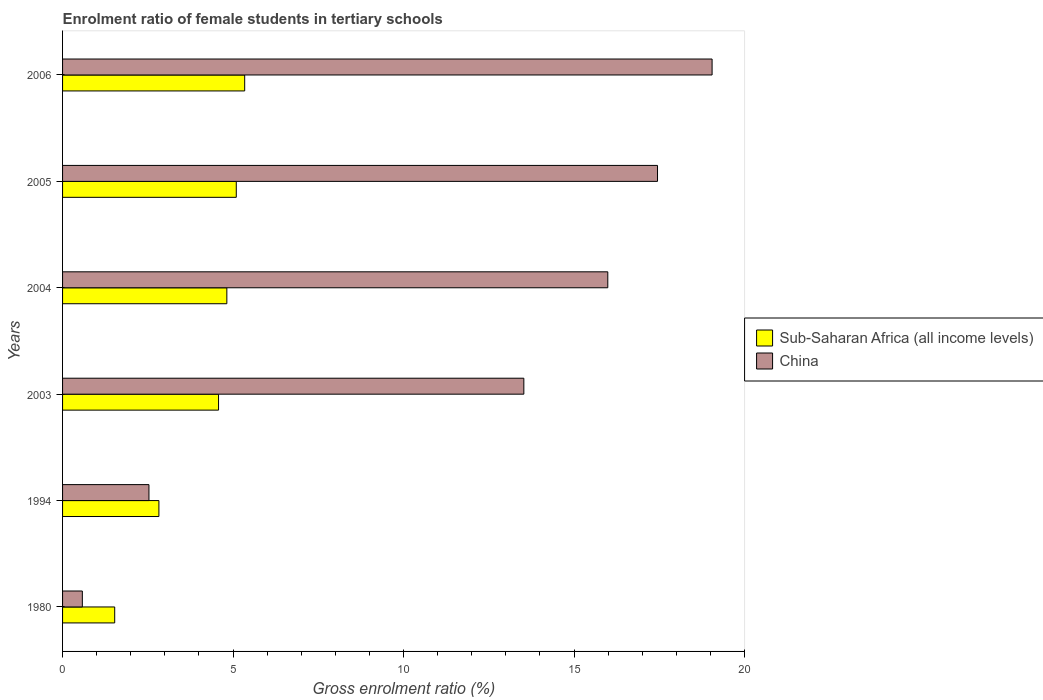How many groups of bars are there?
Provide a short and direct response. 6. How many bars are there on the 1st tick from the bottom?
Your answer should be very brief. 2. What is the enrolment ratio of female students in tertiary schools in Sub-Saharan Africa (all income levels) in 2005?
Provide a succinct answer. 5.09. Across all years, what is the maximum enrolment ratio of female students in tertiary schools in China?
Offer a very short reply. 19.05. Across all years, what is the minimum enrolment ratio of female students in tertiary schools in Sub-Saharan Africa (all income levels)?
Keep it short and to the point. 1.53. In which year was the enrolment ratio of female students in tertiary schools in Sub-Saharan Africa (all income levels) minimum?
Offer a very short reply. 1980. What is the total enrolment ratio of female students in tertiary schools in China in the graph?
Provide a short and direct response. 69.13. What is the difference between the enrolment ratio of female students in tertiary schools in China in 2003 and that in 2005?
Make the answer very short. -3.92. What is the difference between the enrolment ratio of female students in tertiary schools in Sub-Saharan Africa (all income levels) in 2006 and the enrolment ratio of female students in tertiary schools in China in 2003?
Keep it short and to the point. -8.19. What is the average enrolment ratio of female students in tertiary schools in Sub-Saharan Africa (all income levels) per year?
Provide a succinct answer. 4.03. In the year 2003, what is the difference between the enrolment ratio of female students in tertiary schools in China and enrolment ratio of female students in tertiary schools in Sub-Saharan Africa (all income levels)?
Keep it short and to the point. 8.95. What is the ratio of the enrolment ratio of female students in tertiary schools in China in 1980 to that in 1994?
Keep it short and to the point. 0.23. Is the enrolment ratio of female students in tertiary schools in China in 1980 less than that in 1994?
Give a very brief answer. Yes. What is the difference between the highest and the second highest enrolment ratio of female students in tertiary schools in Sub-Saharan Africa (all income levels)?
Give a very brief answer. 0.25. What is the difference between the highest and the lowest enrolment ratio of female students in tertiary schools in China?
Ensure brevity in your answer.  18.47. In how many years, is the enrolment ratio of female students in tertiary schools in Sub-Saharan Africa (all income levels) greater than the average enrolment ratio of female students in tertiary schools in Sub-Saharan Africa (all income levels) taken over all years?
Keep it short and to the point. 4. Is the sum of the enrolment ratio of female students in tertiary schools in Sub-Saharan Africa (all income levels) in 2004 and 2006 greater than the maximum enrolment ratio of female students in tertiary schools in China across all years?
Provide a short and direct response. No. What does the 2nd bar from the top in 2005 represents?
Ensure brevity in your answer.  Sub-Saharan Africa (all income levels). What does the 2nd bar from the bottom in 1994 represents?
Provide a succinct answer. China. How many bars are there?
Your response must be concise. 12. Are all the bars in the graph horizontal?
Keep it short and to the point. Yes. Are the values on the major ticks of X-axis written in scientific E-notation?
Offer a very short reply. No. Does the graph contain grids?
Your answer should be compact. No. How are the legend labels stacked?
Keep it short and to the point. Vertical. What is the title of the graph?
Your answer should be very brief. Enrolment ratio of female students in tertiary schools. Does "Netherlands" appear as one of the legend labels in the graph?
Make the answer very short. No. What is the label or title of the X-axis?
Provide a succinct answer. Gross enrolment ratio (%). What is the label or title of the Y-axis?
Offer a terse response. Years. What is the Gross enrolment ratio (%) of Sub-Saharan Africa (all income levels) in 1980?
Keep it short and to the point. 1.53. What is the Gross enrolment ratio (%) of China in 1980?
Give a very brief answer. 0.58. What is the Gross enrolment ratio (%) of Sub-Saharan Africa (all income levels) in 1994?
Make the answer very short. 2.83. What is the Gross enrolment ratio (%) in China in 1994?
Offer a very short reply. 2.53. What is the Gross enrolment ratio (%) in Sub-Saharan Africa (all income levels) in 2003?
Offer a terse response. 4.57. What is the Gross enrolment ratio (%) of China in 2003?
Make the answer very short. 13.53. What is the Gross enrolment ratio (%) of Sub-Saharan Africa (all income levels) in 2004?
Offer a terse response. 4.82. What is the Gross enrolment ratio (%) in China in 2004?
Offer a very short reply. 15.99. What is the Gross enrolment ratio (%) in Sub-Saharan Africa (all income levels) in 2005?
Give a very brief answer. 5.09. What is the Gross enrolment ratio (%) in China in 2005?
Keep it short and to the point. 17.45. What is the Gross enrolment ratio (%) in Sub-Saharan Africa (all income levels) in 2006?
Offer a terse response. 5.34. What is the Gross enrolment ratio (%) of China in 2006?
Offer a very short reply. 19.05. Across all years, what is the maximum Gross enrolment ratio (%) in Sub-Saharan Africa (all income levels)?
Provide a succinct answer. 5.34. Across all years, what is the maximum Gross enrolment ratio (%) in China?
Give a very brief answer. 19.05. Across all years, what is the minimum Gross enrolment ratio (%) in Sub-Saharan Africa (all income levels)?
Ensure brevity in your answer.  1.53. Across all years, what is the minimum Gross enrolment ratio (%) of China?
Provide a short and direct response. 0.58. What is the total Gross enrolment ratio (%) of Sub-Saharan Africa (all income levels) in the graph?
Ensure brevity in your answer.  24.18. What is the total Gross enrolment ratio (%) in China in the graph?
Ensure brevity in your answer.  69.13. What is the difference between the Gross enrolment ratio (%) of Sub-Saharan Africa (all income levels) in 1980 and that in 1994?
Provide a succinct answer. -1.3. What is the difference between the Gross enrolment ratio (%) of China in 1980 and that in 1994?
Offer a very short reply. -1.95. What is the difference between the Gross enrolment ratio (%) of Sub-Saharan Africa (all income levels) in 1980 and that in 2003?
Offer a terse response. -3.05. What is the difference between the Gross enrolment ratio (%) in China in 1980 and that in 2003?
Provide a short and direct response. -12.95. What is the difference between the Gross enrolment ratio (%) of Sub-Saharan Africa (all income levels) in 1980 and that in 2004?
Provide a short and direct response. -3.29. What is the difference between the Gross enrolment ratio (%) of China in 1980 and that in 2004?
Provide a succinct answer. -15.41. What is the difference between the Gross enrolment ratio (%) of Sub-Saharan Africa (all income levels) in 1980 and that in 2005?
Offer a terse response. -3.57. What is the difference between the Gross enrolment ratio (%) of China in 1980 and that in 2005?
Your answer should be very brief. -16.87. What is the difference between the Gross enrolment ratio (%) of Sub-Saharan Africa (all income levels) in 1980 and that in 2006?
Your answer should be compact. -3.81. What is the difference between the Gross enrolment ratio (%) of China in 1980 and that in 2006?
Your answer should be compact. -18.47. What is the difference between the Gross enrolment ratio (%) of Sub-Saharan Africa (all income levels) in 1994 and that in 2003?
Offer a very short reply. -1.75. What is the difference between the Gross enrolment ratio (%) in China in 1994 and that in 2003?
Provide a short and direct response. -11. What is the difference between the Gross enrolment ratio (%) in Sub-Saharan Africa (all income levels) in 1994 and that in 2004?
Provide a succinct answer. -1.99. What is the difference between the Gross enrolment ratio (%) of China in 1994 and that in 2004?
Ensure brevity in your answer.  -13.46. What is the difference between the Gross enrolment ratio (%) of Sub-Saharan Africa (all income levels) in 1994 and that in 2005?
Give a very brief answer. -2.27. What is the difference between the Gross enrolment ratio (%) of China in 1994 and that in 2005?
Provide a succinct answer. -14.92. What is the difference between the Gross enrolment ratio (%) of Sub-Saharan Africa (all income levels) in 1994 and that in 2006?
Ensure brevity in your answer.  -2.52. What is the difference between the Gross enrolment ratio (%) in China in 1994 and that in 2006?
Offer a terse response. -16.52. What is the difference between the Gross enrolment ratio (%) of Sub-Saharan Africa (all income levels) in 2003 and that in 2004?
Offer a terse response. -0.24. What is the difference between the Gross enrolment ratio (%) in China in 2003 and that in 2004?
Your answer should be compact. -2.46. What is the difference between the Gross enrolment ratio (%) of Sub-Saharan Africa (all income levels) in 2003 and that in 2005?
Ensure brevity in your answer.  -0.52. What is the difference between the Gross enrolment ratio (%) in China in 2003 and that in 2005?
Provide a succinct answer. -3.92. What is the difference between the Gross enrolment ratio (%) in Sub-Saharan Africa (all income levels) in 2003 and that in 2006?
Keep it short and to the point. -0.77. What is the difference between the Gross enrolment ratio (%) of China in 2003 and that in 2006?
Your response must be concise. -5.52. What is the difference between the Gross enrolment ratio (%) in Sub-Saharan Africa (all income levels) in 2004 and that in 2005?
Provide a succinct answer. -0.28. What is the difference between the Gross enrolment ratio (%) of China in 2004 and that in 2005?
Offer a terse response. -1.46. What is the difference between the Gross enrolment ratio (%) in Sub-Saharan Africa (all income levels) in 2004 and that in 2006?
Keep it short and to the point. -0.52. What is the difference between the Gross enrolment ratio (%) of China in 2004 and that in 2006?
Provide a short and direct response. -3.06. What is the difference between the Gross enrolment ratio (%) of Sub-Saharan Africa (all income levels) in 2005 and that in 2006?
Give a very brief answer. -0.25. What is the difference between the Gross enrolment ratio (%) in China in 2005 and that in 2006?
Provide a short and direct response. -1.6. What is the difference between the Gross enrolment ratio (%) in Sub-Saharan Africa (all income levels) in 1980 and the Gross enrolment ratio (%) in China in 1994?
Offer a very short reply. -1. What is the difference between the Gross enrolment ratio (%) in Sub-Saharan Africa (all income levels) in 1980 and the Gross enrolment ratio (%) in China in 2003?
Keep it short and to the point. -12. What is the difference between the Gross enrolment ratio (%) in Sub-Saharan Africa (all income levels) in 1980 and the Gross enrolment ratio (%) in China in 2004?
Provide a short and direct response. -14.46. What is the difference between the Gross enrolment ratio (%) in Sub-Saharan Africa (all income levels) in 1980 and the Gross enrolment ratio (%) in China in 2005?
Your response must be concise. -15.92. What is the difference between the Gross enrolment ratio (%) of Sub-Saharan Africa (all income levels) in 1980 and the Gross enrolment ratio (%) of China in 2006?
Provide a short and direct response. -17.52. What is the difference between the Gross enrolment ratio (%) of Sub-Saharan Africa (all income levels) in 1994 and the Gross enrolment ratio (%) of China in 2003?
Your answer should be very brief. -10.7. What is the difference between the Gross enrolment ratio (%) in Sub-Saharan Africa (all income levels) in 1994 and the Gross enrolment ratio (%) in China in 2004?
Offer a terse response. -13.17. What is the difference between the Gross enrolment ratio (%) of Sub-Saharan Africa (all income levels) in 1994 and the Gross enrolment ratio (%) of China in 2005?
Your response must be concise. -14.62. What is the difference between the Gross enrolment ratio (%) of Sub-Saharan Africa (all income levels) in 1994 and the Gross enrolment ratio (%) of China in 2006?
Give a very brief answer. -16.22. What is the difference between the Gross enrolment ratio (%) of Sub-Saharan Africa (all income levels) in 2003 and the Gross enrolment ratio (%) of China in 2004?
Make the answer very short. -11.42. What is the difference between the Gross enrolment ratio (%) of Sub-Saharan Africa (all income levels) in 2003 and the Gross enrolment ratio (%) of China in 2005?
Keep it short and to the point. -12.87. What is the difference between the Gross enrolment ratio (%) in Sub-Saharan Africa (all income levels) in 2003 and the Gross enrolment ratio (%) in China in 2006?
Ensure brevity in your answer.  -14.48. What is the difference between the Gross enrolment ratio (%) in Sub-Saharan Africa (all income levels) in 2004 and the Gross enrolment ratio (%) in China in 2005?
Ensure brevity in your answer.  -12.63. What is the difference between the Gross enrolment ratio (%) of Sub-Saharan Africa (all income levels) in 2004 and the Gross enrolment ratio (%) of China in 2006?
Offer a very short reply. -14.23. What is the difference between the Gross enrolment ratio (%) in Sub-Saharan Africa (all income levels) in 2005 and the Gross enrolment ratio (%) in China in 2006?
Your answer should be compact. -13.96. What is the average Gross enrolment ratio (%) of Sub-Saharan Africa (all income levels) per year?
Your response must be concise. 4.03. What is the average Gross enrolment ratio (%) in China per year?
Your answer should be very brief. 11.52. In the year 1980, what is the difference between the Gross enrolment ratio (%) in Sub-Saharan Africa (all income levels) and Gross enrolment ratio (%) in China?
Offer a terse response. 0.95. In the year 1994, what is the difference between the Gross enrolment ratio (%) in Sub-Saharan Africa (all income levels) and Gross enrolment ratio (%) in China?
Your response must be concise. 0.29. In the year 2003, what is the difference between the Gross enrolment ratio (%) of Sub-Saharan Africa (all income levels) and Gross enrolment ratio (%) of China?
Provide a short and direct response. -8.95. In the year 2004, what is the difference between the Gross enrolment ratio (%) of Sub-Saharan Africa (all income levels) and Gross enrolment ratio (%) of China?
Your answer should be compact. -11.17. In the year 2005, what is the difference between the Gross enrolment ratio (%) in Sub-Saharan Africa (all income levels) and Gross enrolment ratio (%) in China?
Your response must be concise. -12.35. In the year 2006, what is the difference between the Gross enrolment ratio (%) of Sub-Saharan Africa (all income levels) and Gross enrolment ratio (%) of China?
Your response must be concise. -13.71. What is the ratio of the Gross enrolment ratio (%) of Sub-Saharan Africa (all income levels) in 1980 to that in 1994?
Make the answer very short. 0.54. What is the ratio of the Gross enrolment ratio (%) in China in 1980 to that in 1994?
Offer a very short reply. 0.23. What is the ratio of the Gross enrolment ratio (%) of Sub-Saharan Africa (all income levels) in 1980 to that in 2003?
Give a very brief answer. 0.33. What is the ratio of the Gross enrolment ratio (%) in China in 1980 to that in 2003?
Offer a terse response. 0.04. What is the ratio of the Gross enrolment ratio (%) in Sub-Saharan Africa (all income levels) in 1980 to that in 2004?
Provide a short and direct response. 0.32. What is the ratio of the Gross enrolment ratio (%) in China in 1980 to that in 2004?
Your answer should be compact. 0.04. What is the ratio of the Gross enrolment ratio (%) of Sub-Saharan Africa (all income levels) in 1980 to that in 2005?
Your answer should be compact. 0.3. What is the ratio of the Gross enrolment ratio (%) of China in 1980 to that in 2005?
Keep it short and to the point. 0.03. What is the ratio of the Gross enrolment ratio (%) in Sub-Saharan Africa (all income levels) in 1980 to that in 2006?
Provide a succinct answer. 0.29. What is the ratio of the Gross enrolment ratio (%) in China in 1980 to that in 2006?
Ensure brevity in your answer.  0.03. What is the ratio of the Gross enrolment ratio (%) of Sub-Saharan Africa (all income levels) in 1994 to that in 2003?
Provide a short and direct response. 0.62. What is the ratio of the Gross enrolment ratio (%) of China in 1994 to that in 2003?
Give a very brief answer. 0.19. What is the ratio of the Gross enrolment ratio (%) of Sub-Saharan Africa (all income levels) in 1994 to that in 2004?
Your answer should be very brief. 0.59. What is the ratio of the Gross enrolment ratio (%) in China in 1994 to that in 2004?
Provide a short and direct response. 0.16. What is the ratio of the Gross enrolment ratio (%) of Sub-Saharan Africa (all income levels) in 1994 to that in 2005?
Your answer should be very brief. 0.55. What is the ratio of the Gross enrolment ratio (%) of China in 1994 to that in 2005?
Your answer should be very brief. 0.15. What is the ratio of the Gross enrolment ratio (%) of Sub-Saharan Africa (all income levels) in 1994 to that in 2006?
Offer a very short reply. 0.53. What is the ratio of the Gross enrolment ratio (%) of China in 1994 to that in 2006?
Offer a terse response. 0.13. What is the ratio of the Gross enrolment ratio (%) in Sub-Saharan Africa (all income levels) in 2003 to that in 2004?
Give a very brief answer. 0.95. What is the ratio of the Gross enrolment ratio (%) in China in 2003 to that in 2004?
Keep it short and to the point. 0.85. What is the ratio of the Gross enrolment ratio (%) in Sub-Saharan Africa (all income levels) in 2003 to that in 2005?
Keep it short and to the point. 0.9. What is the ratio of the Gross enrolment ratio (%) in China in 2003 to that in 2005?
Provide a short and direct response. 0.78. What is the ratio of the Gross enrolment ratio (%) in Sub-Saharan Africa (all income levels) in 2003 to that in 2006?
Offer a terse response. 0.86. What is the ratio of the Gross enrolment ratio (%) in China in 2003 to that in 2006?
Give a very brief answer. 0.71. What is the ratio of the Gross enrolment ratio (%) in Sub-Saharan Africa (all income levels) in 2004 to that in 2005?
Make the answer very short. 0.95. What is the ratio of the Gross enrolment ratio (%) in China in 2004 to that in 2005?
Ensure brevity in your answer.  0.92. What is the ratio of the Gross enrolment ratio (%) of Sub-Saharan Africa (all income levels) in 2004 to that in 2006?
Your answer should be very brief. 0.9. What is the ratio of the Gross enrolment ratio (%) in China in 2004 to that in 2006?
Make the answer very short. 0.84. What is the ratio of the Gross enrolment ratio (%) of Sub-Saharan Africa (all income levels) in 2005 to that in 2006?
Your answer should be very brief. 0.95. What is the ratio of the Gross enrolment ratio (%) in China in 2005 to that in 2006?
Give a very brief answer. 0.92. What is the difference between the highest and the second highest Gross enrolment ratio (%) of Sub-Saharan Africa (all income levels)?
Make the answer very short. 0.25. What is the difference between the highest and the second highest Gross enrolment ratio (%) of China?
Give a very brief answer. 1.6. What is the difference between the highest and the lowest Gross enrolment ratio (%) of Sub-Saharan Africa (all income levels)?
Provide a succinct answer. 3.81. What is the difference between the highest and the lowest Gross enrolment ratio (%) of China?
Your answer should be very brief. 18.47. 